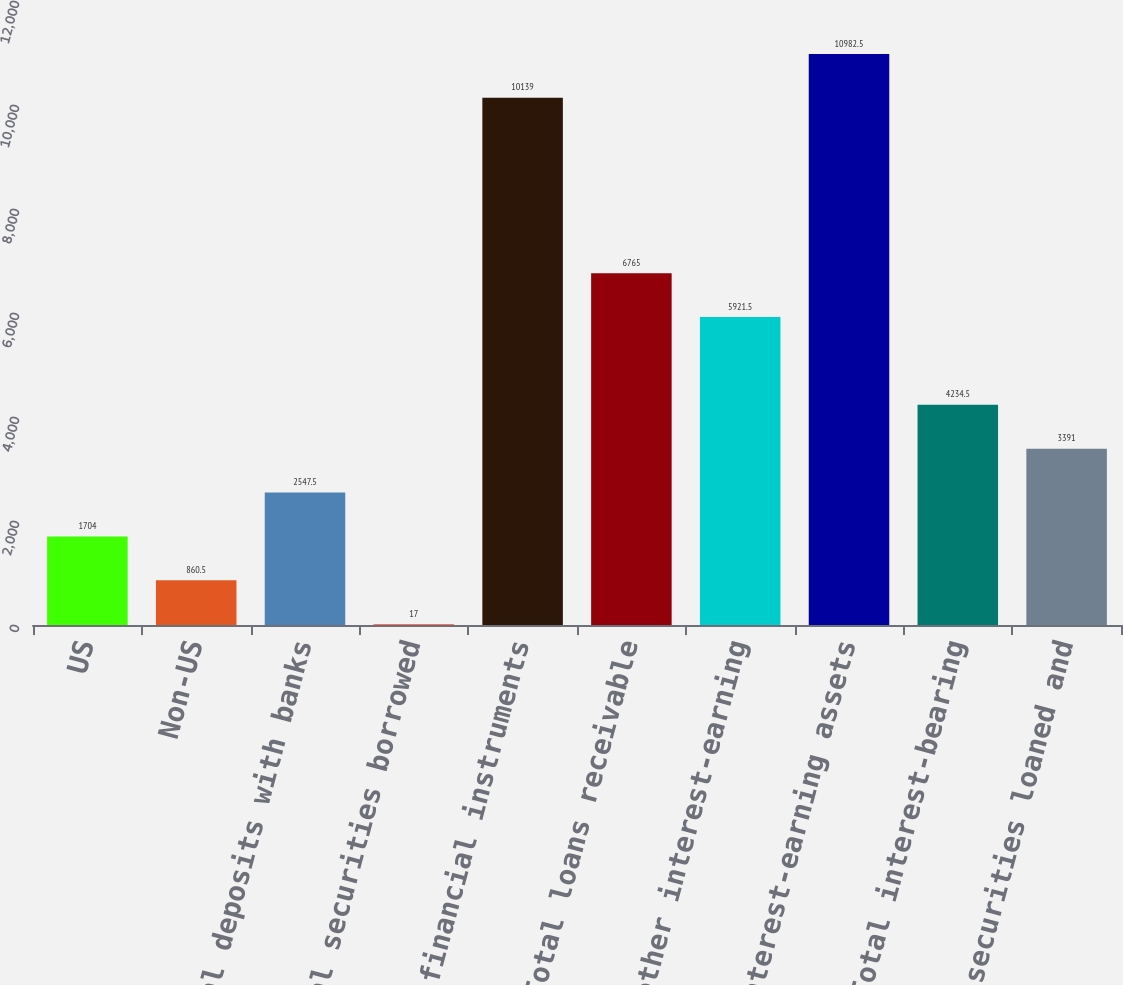Convert chart. <chart><loc_0><loc_0><loc_500><loc_500><bar_chart><fcel>US<fcel>Non-US<fcel>Total deposits with banks<fcel>Total securities borrowed<fcel>Total financial instruments<fcel>Total loans receivable<fcel>Total other interest-earning<fcel>Total interest-earning assets<fcel>Total interest-bearing<fcel>Total securities loaned and<nl><fcel>1704<fcel>860.5<fcel>2547.5<fcel>17<fcel>10139<fcel>6765<fcel>5921.5<fcel>10982.5<fcel>4234.5<fcel>3391<nl></chart> 